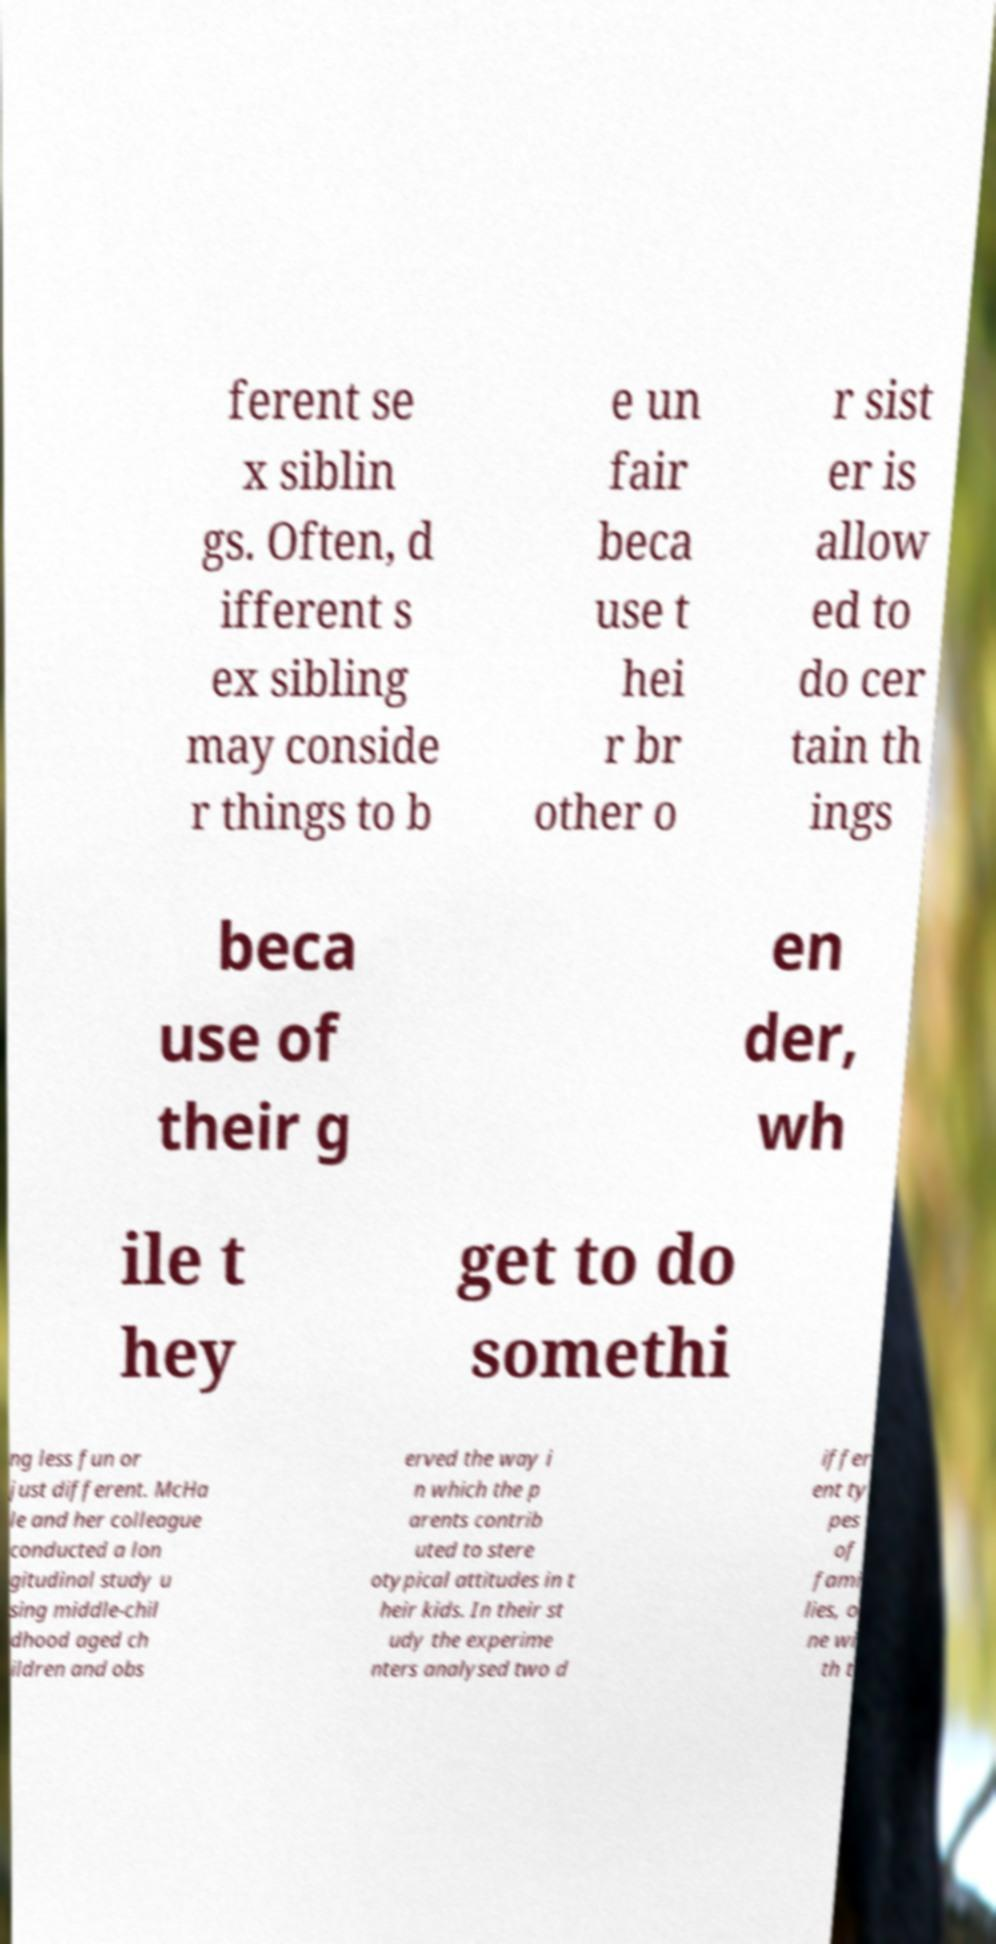Can you accurately transcribe the text from the provided image for me? ferent se x siblin gs. Often, d ifferent s ex sibling may conside r things to b e un fair beca use t hei r br other o r sist er is allow ed to do cer tain th ings beca use of their g en der, wh ile t hey get to do somethi ng less fun or just different. McHa le and her colleague conducted a lon gitudinal study u sing middle-chil dhood aged ch ildren and obs erved the way i n which the p arents contrib uted to stere otypical attitudes in t heir kids. In their st udy the experime nters analysed two d iffer ent ty pes of fami lies, o ne wi th t 